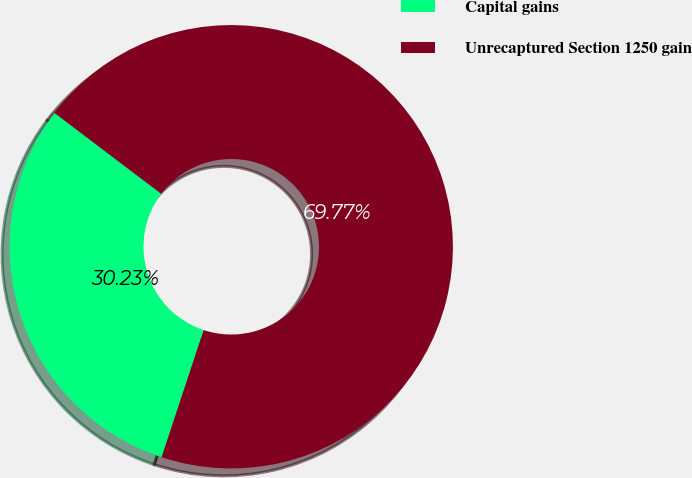<chart> <loc_0><loc_0><loc_500><loc_500><pie_chart><fcel>Capital gains<fcel>Unrecaptured Section 1250 gain<nl><fcel>30.23%<fcel>69.77%<nl></chart> 